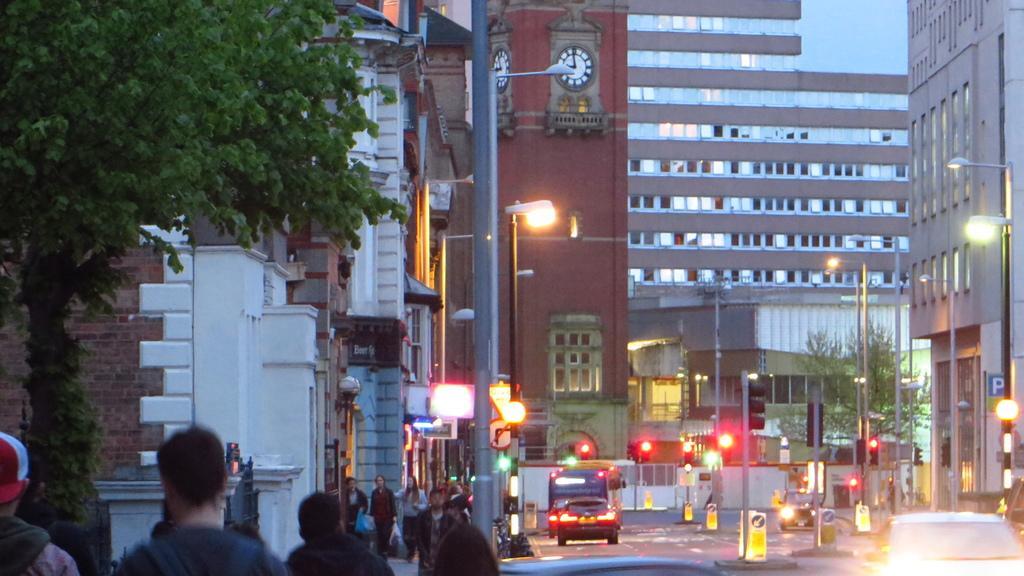How would you summarize this image in a sentence or two? In this image we can see there are buildings and trees. And there are people walking and holding covers. And there are vehicles on the road. And there are poles, street lights, light poles and sign boards. 